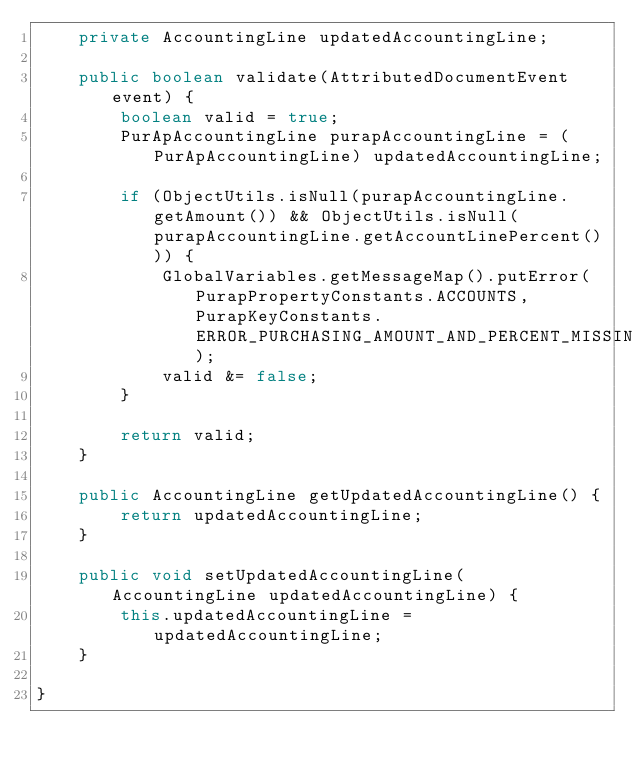<code> <loc_0><loc_0><loc_500><loc_500><_Java_>    private AccountingLine updatedAccountingLine;

    public boolean validate(AttributedDocumentEvent event) {
        boolean valid = true;
        PurApAccountingLine purapAccountingLine = (PurApAccountingLine) updatedAccountingLine;

        if (ObjectUtils.isNull(purapAccountingLine.getAmount()) && ObjectUtils.isNull(purapAccountingLine.getAccountLinePercent())) {
            GlobalVariables.getMessageMap().putError(PurapPropertyConstants.ACCOUNTS, PurapKeyConstants.ERROR_PURCHASING_AMOUNT_AND_PERCENT_MISSING);
            valid &= false;
        }

        return valid;
    }

    public AccountingLine getUpdatedAccountingLine() {
        return updatedAccountingLine;
    }

    public void setUpdatedAccountingLine(AccountingLine updatedAccountingLine) {
        this.updatedAccountingLine = updatedAccountingLine;
    }

}
</code> 